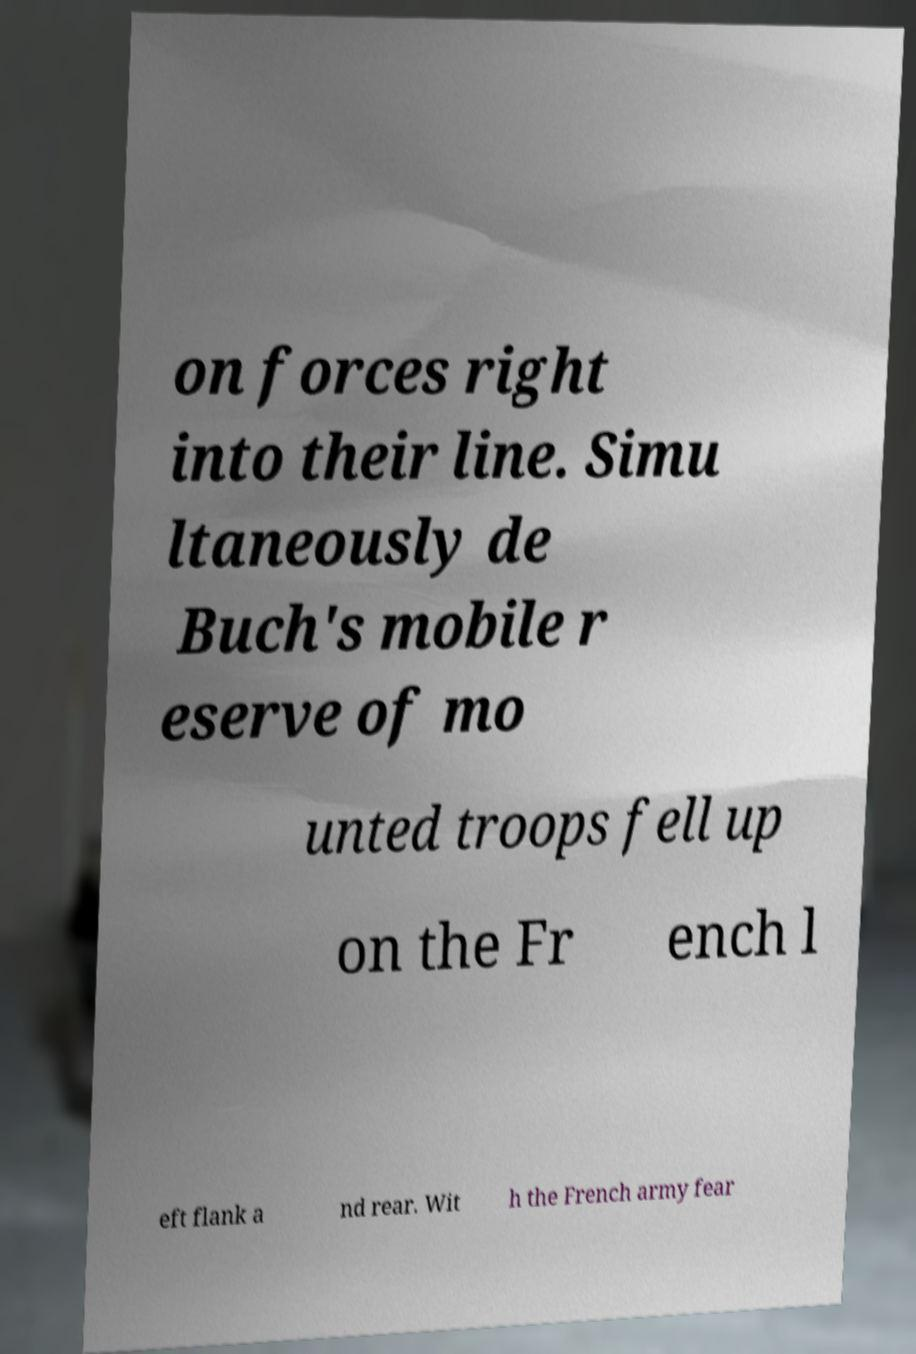I need the written content from this picture converted into text. Can you do that? on forces right into their line. Simu ltaneously de Buch's mobile r eserve of mo unted troops fell up on the Fr ench l eft flank a nd rear. Wit h the French army fear 